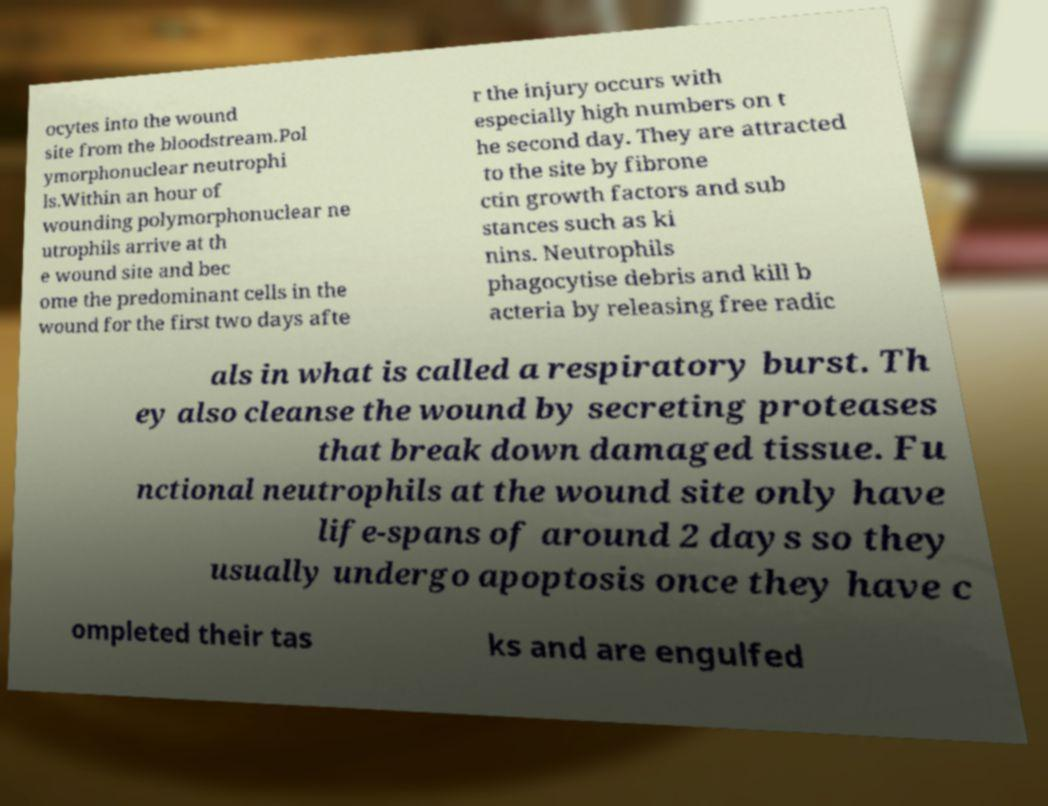Please read and relay the text visible in this image. What does it say? ocytes into the wound site from the bloodstream.Pol ymorphonuclear neutrophi ls.Within an hour of wounding polymorphonuclear ne utrophils arrive at th e wound site and bec ome the predominant cells in the wound for the first two days afte r the injury occurs with especially high numbers on t he second day. They are attracted to the site by fibrone ctin growth factors and sub stances such as ki nins. Neutrophils phagocytise debris and kill b acteria by releasing free radic als in what is called a respiratory burst. Th ey also cleanse the wound by secreting proteases that break down damaged tissue. Fu nctional neutrophils at the wound site only have life-spans of around 2 days so they usually undergo apoptosis once they have c ompleted their tas ks and are engulfed 